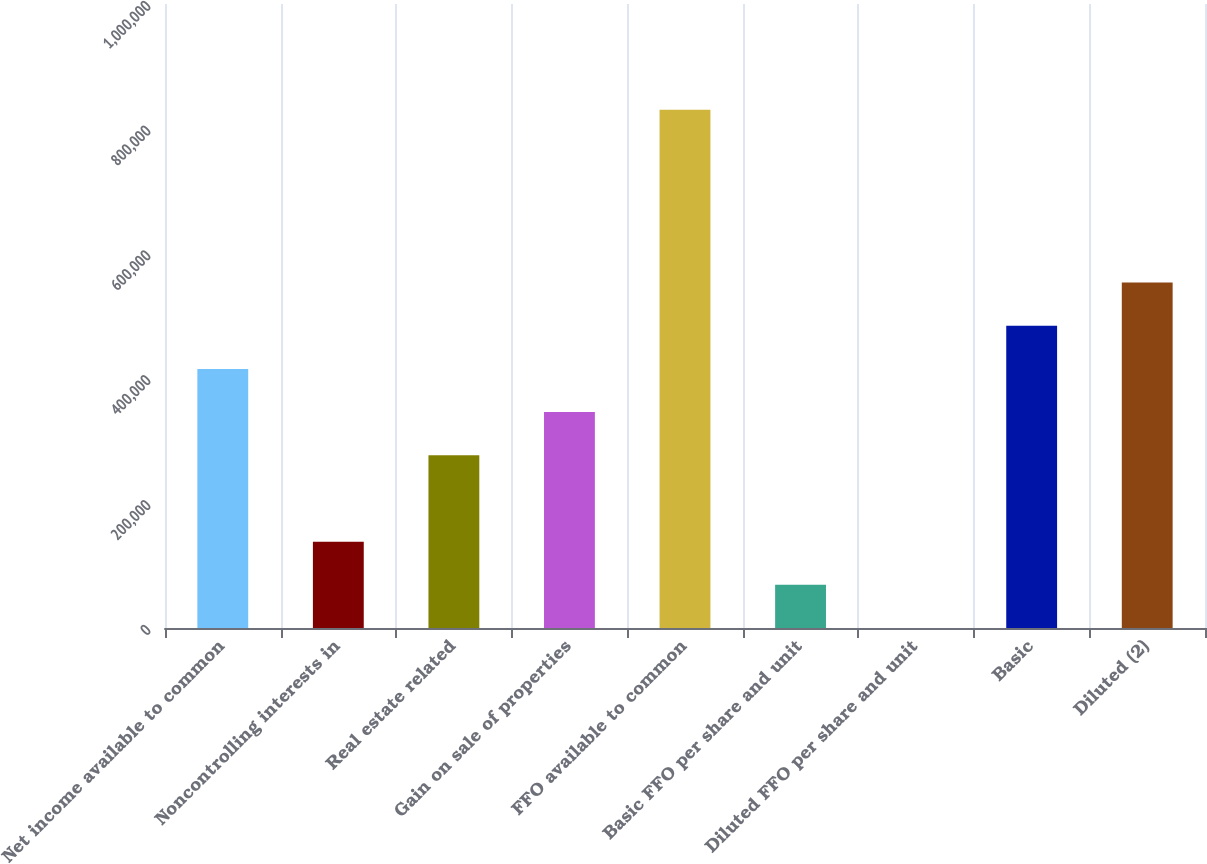Convert chart to OTSL. <chart><loc_0><loc_0><loc_500><loc_500><bar_chart><fcel>Net income available to common<fcel>Noncontrolling interests in<fcel>Real estate related<fcel>Gain on sale of properties<fcel>FFO available to common<fcel>Basic FFO per share and unit<fcel>Diluted FFO per share and unit<fcel>Basic<fcel>Diluted (2)<nl><fcel>415182<fcel>138397<fcel>276789<fcel>345986<fcel>830358<fcel>69201.1<fcel>5.04<fcel>484378<fcel>553574<nl></chart> 